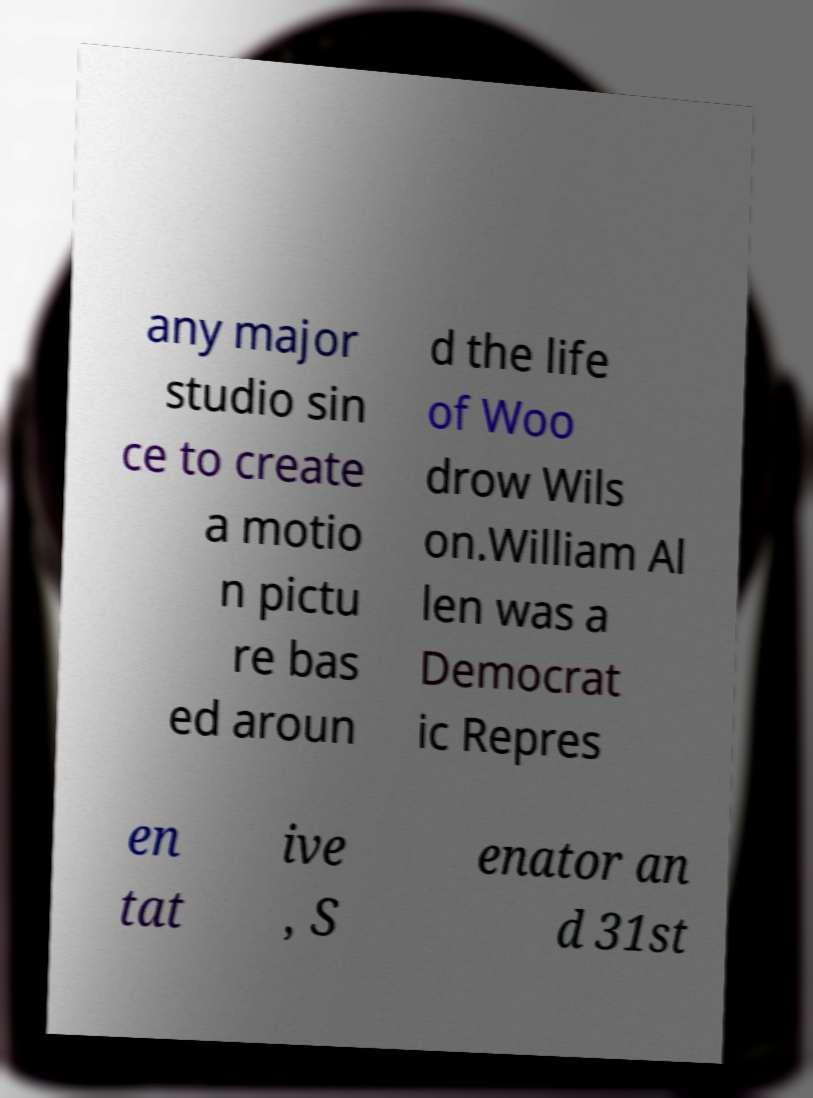Could you extract and type out the text from this image? any major studio sin ce to create a motio n pictu re bas ed aroun d the life of Woo drow Wils on.William Al len was a Democrat ic Repres en tat ive , S enator an d 31st 